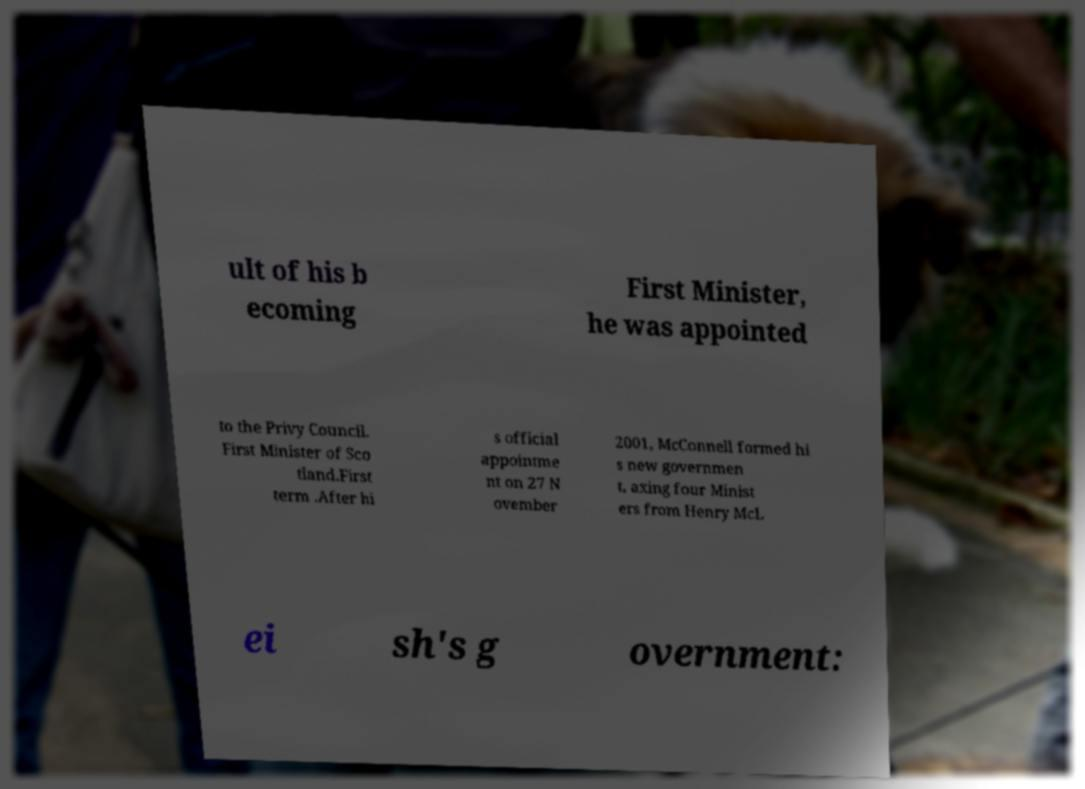I need the written content from this picture converted into text. Can you do that? ult of his b ecoming First Minister, he was appointed to the Privy Council. First Minister of Sco tland.First term .After hi s official appointme nt on 27 N ovember 2001, McConnell formed hi s new governmen t, axing four Minist ers from Henry McL ei sh's g overnment: 